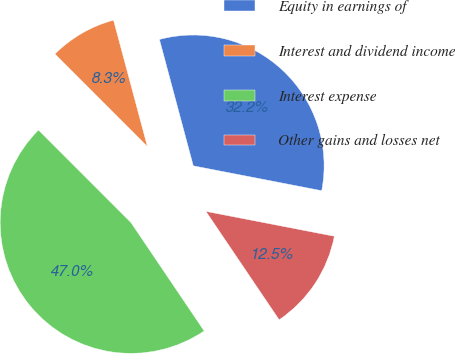Convert chart. <chart><loc_0><loc_0><loc_500><loc_500><pie_chart><fcel>Equity in earnings of<fcel>Interest and dividend income<fcel>Interest expense<fcel>Other gains and losses net<nl><fcel>32.21%<fcel>8.33%<fcel>46.96%<fcel>12.5%<nl></chart> 